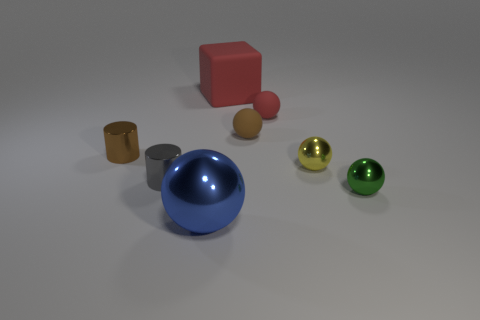How many big things are either gray rubber objects or brown rubber spheres? In the image, 'big' is a relative term, but based on the context, one could argue that the large blue sphere is a significant object of focus. However, it's neither gray nor brown as specified in the query. There are no gray rubber objects or brown rubber spheres that can be considered 'big'. Therefore, the original answer of '0' is accurate, but it's important to consider context when interpreting the question. 